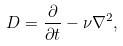<formula> <loc_0><loc_0><loc_500><loc_500>D = \frac { \partial } { \partial t } - \nu \nabla ^ { 2 } ,</formula> 